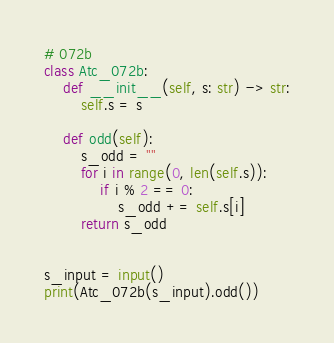Convert code to text. <code><loc_0><loc_0><loc_500><loc_500><_Python_># 072b
class Atc_072b:
    def __init__(self, s: str) -> str:
        self.s = s

    def odd(self):
        s_odd = ""
        for i in range(0, len(self.s)):
            if i % 2 == 0:
                s_odd += self.s[i]
        return s_odd
    

s_input = input()
print(Atc_072b(s_input).odd())</code> 